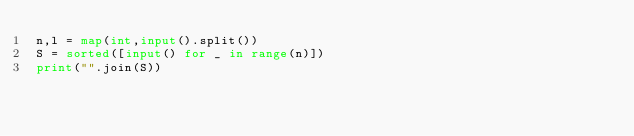<code> <loc_0><loc_0><loc_500><loc_500><_Python_>n,l = map(int,input().split())
S = sorted([input() for _ in range(n)])
print("".join(S))</code> 